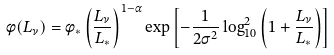Convert formula to latex. <formula><loc_0><loc_0><loc_500><loc_500>\phi ( L _ { \nu } ) = \phi _ { * } \left ( \frac { L _ { \nu } } { L _ { * } } \right ) ^ { 1 - \alpha } \exp \left [ - \frac { 1 } { 2 \sigma ^ { 2 } } \log _ { 1 0 } ^ { 2 } \left ( 1 + \frac { L _ { \nu } } { L _ { * } } \right ) \right ]</formula> 